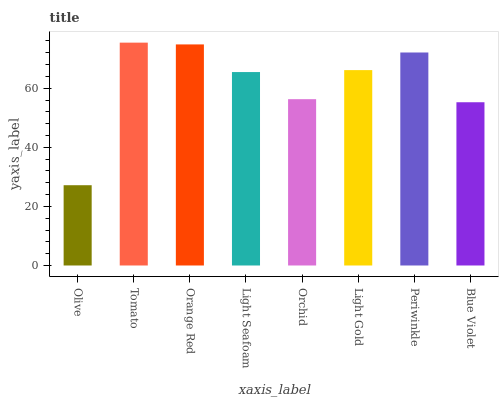Is Olive the minimum?
Answer yes or no. Yes. Is Tomato the maximum?
Answer yes or no. Yes. Is Orange Red the minimum?
Answer yes or no. No. Is Orange Red the maximum?
Answer yes or no. No. Is Tomato greater than Orange Red?
Answer yes or no. Yes. Is Orange Red less than Tomato?
Answer yes or no. Yes. Is Orange Red greater than Tomato?
Answer yes or no. No. Is Tomato less than Orange Red?
Answer yes or no. No. Is Light Gold the high median?
Answer yes or no. Yes. Is Light Seafoam the low median?
Answer yes or no. Yes. Is Light Seafoam the high median?
Answer yes or no. No. Is Periwinkle the low median?
Answer yes or no. No. 